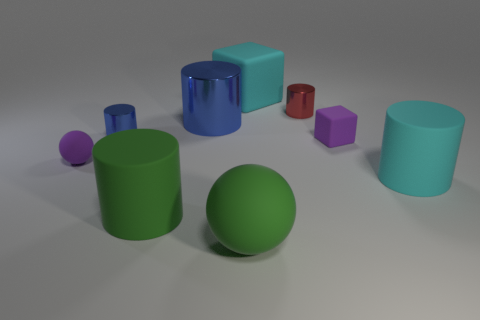What is the material of the tiny cylinder that is the same color as the big shiny cylinder?
Your answer should be compact. Metal. How many blue metal blocks are there?
Make the answer very short. 0. The small purple rubber thing to the left of the big green rubber ball has what shape?
Provide a short and direct response. Sphere. What color is the rubber sphere that is on the left side of the metal cylinder to the left of the large matte thing on the left side of the big blue metal cylinder?
Ensure brevity in your answer.  Purple. There is a small thing that is the same material as the purple ball; what shape is it?
Ensure brevity in your answer.  Cube. Are there fewer small blue metal blocks than blue shiny cylinders?
Give a very brief answer. Yes. Is the purple sphere made of the same material as the large cyan block?
Give a very brief answer. Yes. Is the number of big red balls greater than the number of green matte things?
Offer a very short reply. No. There is a green ball; is it the same size as the rubber cylinder on the left side of the cyan matte cylinder?
Offer a very short reply. Yes. The large rubber cylinder that is on the left side of the tiny matte cube is what color?
Make the answer very short. Green. 